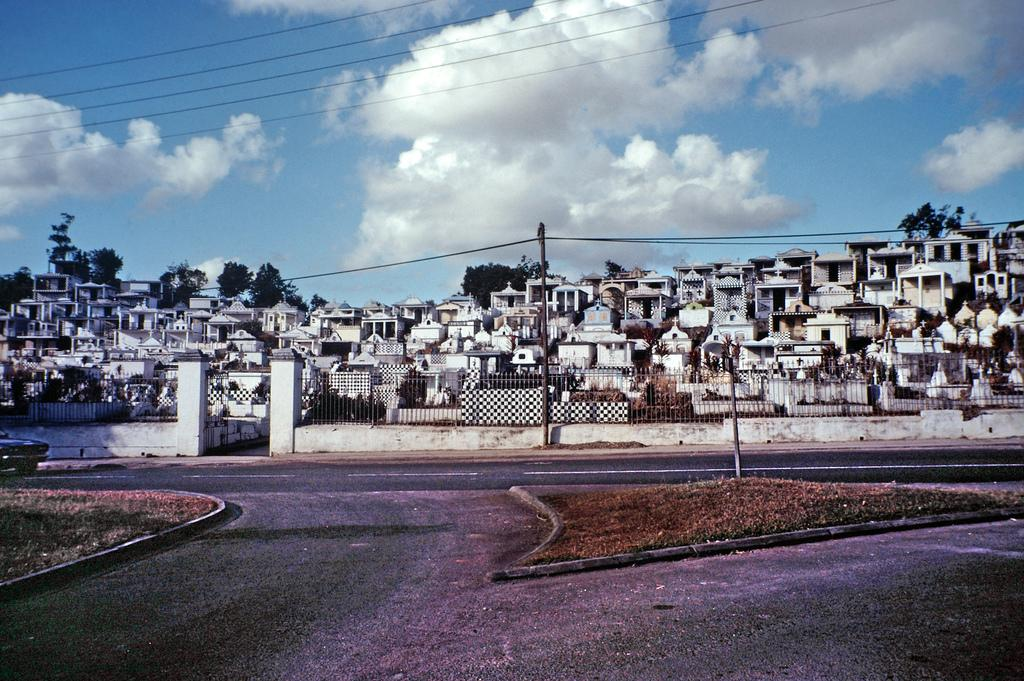What is the main subject of the image? The image depicts a graveyard. Can you describe the features of the graveyard? There are multiple graves within the graveyard. What is located in front of the graveyard? There is a road in front of the graveyard. What can be seen in the background of the image? The sky is visible in the background of the image, and clouds are present. What type of finger can be seen holding a record on a desk in the image? There is no finger, record, or desk present in the image; it depicts a graveyard with multiple graves, a road, and a sky with clouds. 